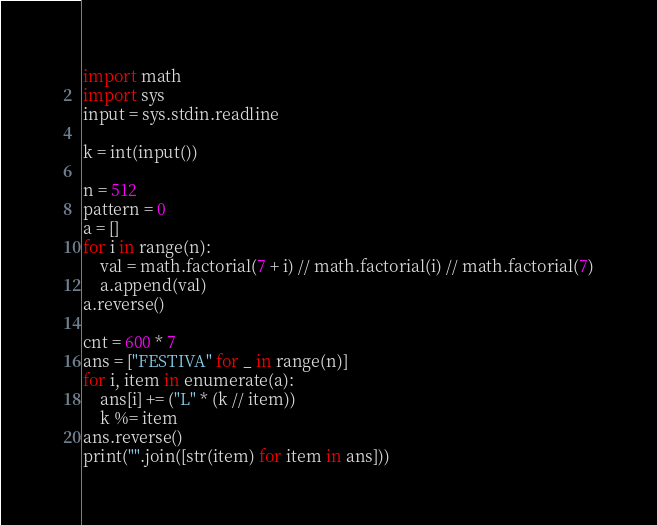Convert code to text. <code><loc_0><loc_0><loc_500><loc_500><_Python_>import math
import sys
input = sys.stdin.readline

k = int(input())

n = 512
pattern = 0
a = []
for i in range(n):
    val = math.factorial(7 + i) // math.factorial(i) // math.factorial(7)
    a.append(val)
a.reverse()

cnt = 600 * 7 
ans = ["FESTIVA" for _ in range(n)]
for i, item in enumerate(a):
    ans[i] += ("L" * (k // item))
    k %= item
ans.reverse()
print("".join([str(item) for item in ans]))</code> 